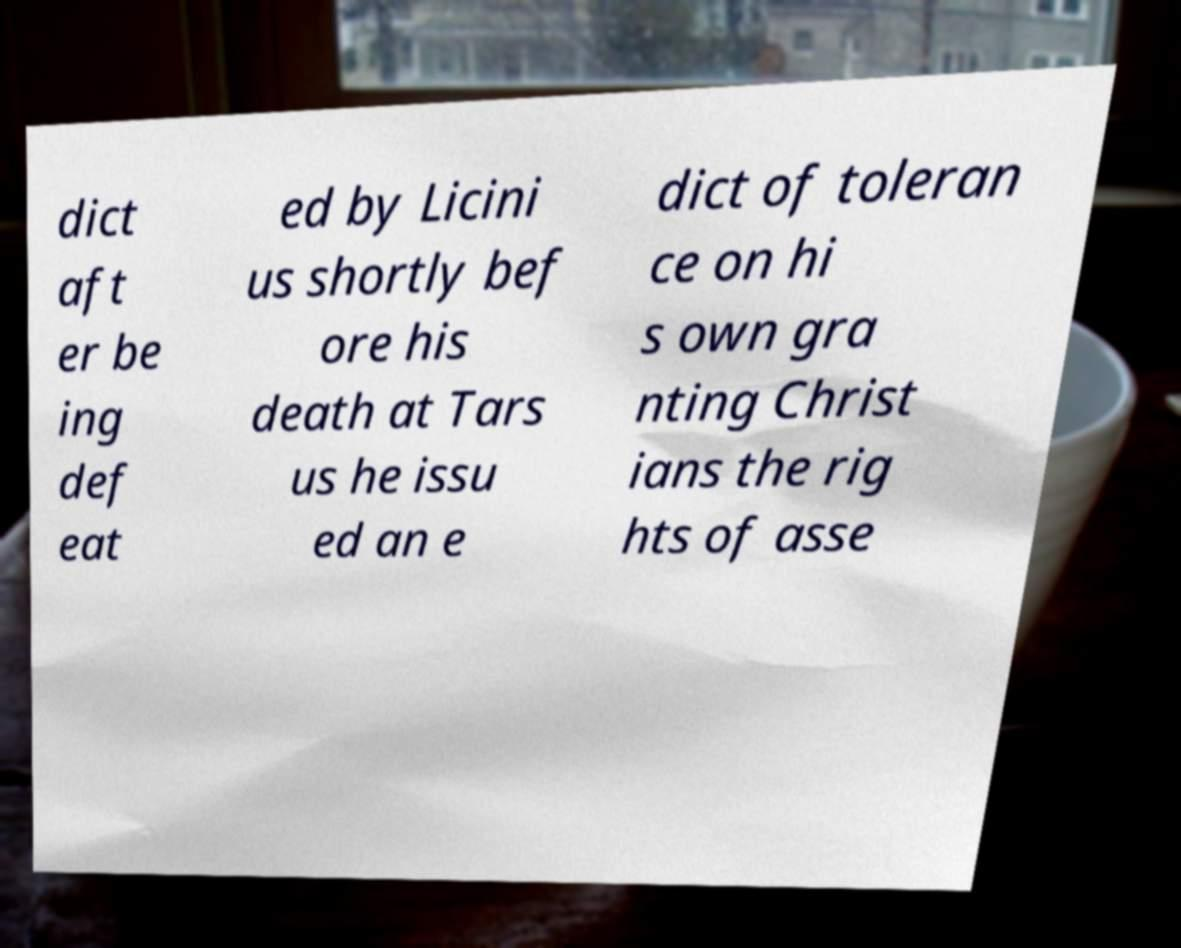Can you read and provide the text displayed in the image?This photo seems to have some interesting text. Can you extract and type it out for me? dict aft er be ing def eat ed by Licini us shortly bef ore his death at Tars us he issu ed an e dict of toleran ce on hi s own gra nting Christ ians the rig hts of asse 